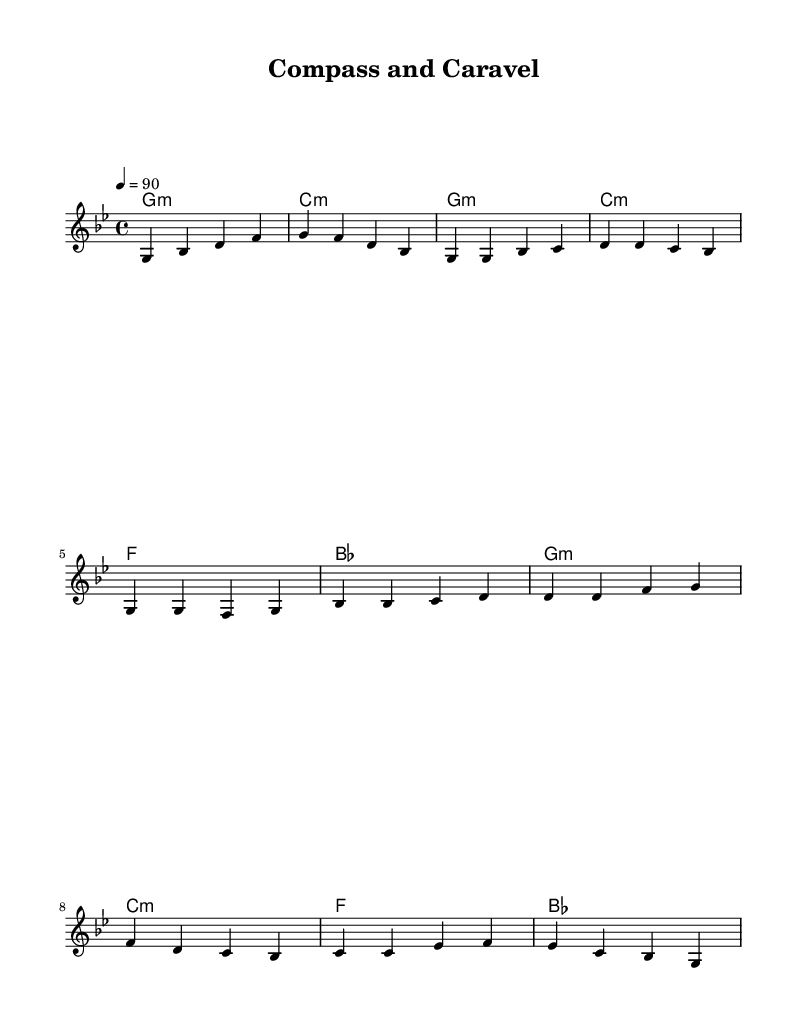What is the key signature of this music? The key signature is G minor, which has two flats (B flat and E flat). It's indicated at the beginning of the staff, which shows the necessary sharps or flats for the key.
Answer: G minor What is the time signature of this piece? The time signature is 4/4, which indicates there are four beats in each measure and that the quarter note gets one beat. This information is usually found at the beginning of the sheet music.
Answer: 4/4 What is the tempo marking for the piece? The tempo marking is 90 beats per minute, which is mentioned just below the time signature. It indicates how fast the piece should be played.
Answer: 90 How many measures are in the chorus section? The chorus is composed of four measures, which can be counted in the written section of the sheet music. It consists of the part labeled as "Chorus".
Answer: 4 What type of harmony is primarily used in this piece? The harmony used is minor, as indicated by the chords labeled with "m" for minor after the chords in the chord mode section.
Answer: Minor Does the melody have repeated phrases? Yes, the melody contains repeated phrases during the verse and chorus sections, where certain motifs are echoed or similar lines occur in sequence.
Answer: Yes 